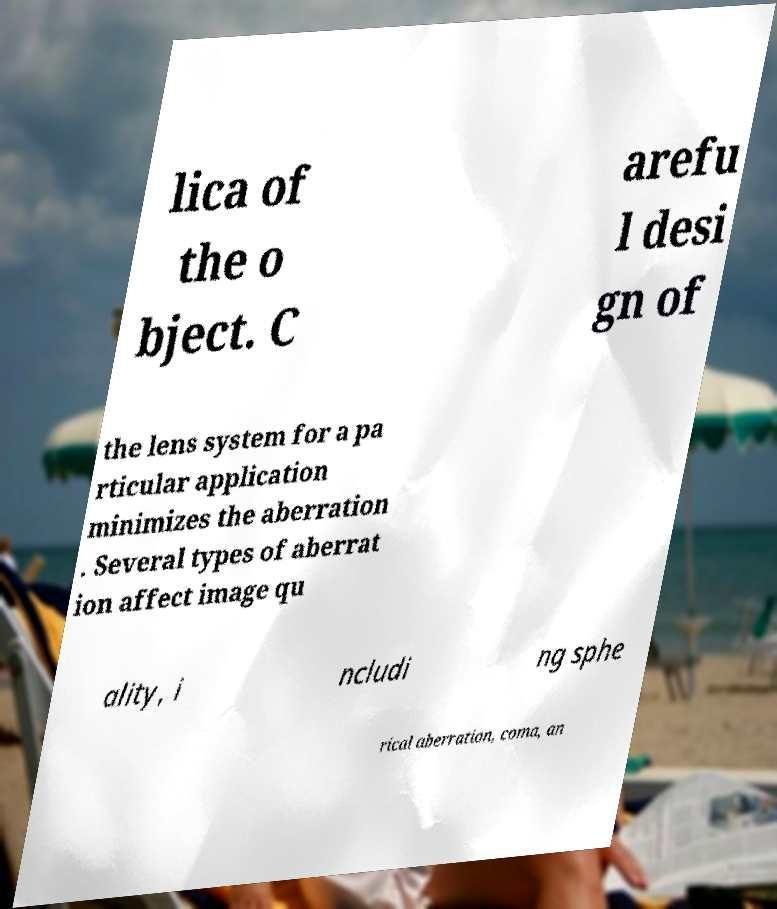Could you extract and type out the text from this image? lica of the o bject. C arefu l desi gn of the lens system for a pa rticular application minimizes the aberration . Several types of aberrat ion affect image qu ality, i ncludi ng sphe rical aberration, coma, an 